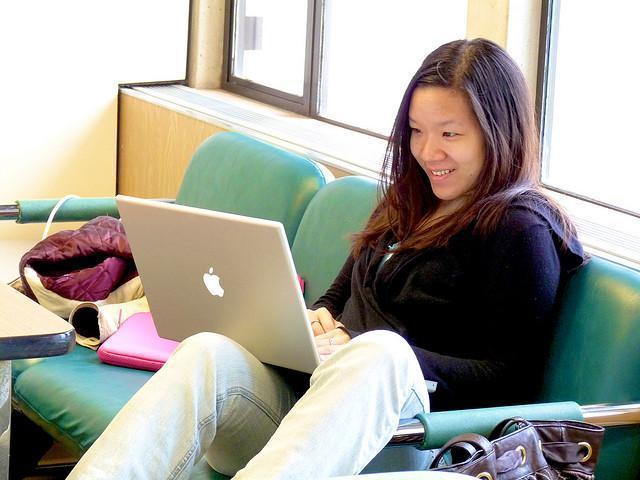How many boats are in the water?
Give a very brief answer. 0. 